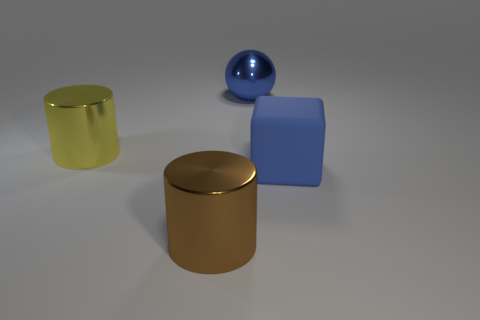Are there any other things that are made of the same material as the blue cube?
Make the answer very short. No. What material is the blue thing that is on the right side of the blue shiny thing?
Your response must be concise. Rubber. Are there fewer blue rubber blocks behind the cube than large matte objects?
Give a very brief answer. Yes. Is the shape of the big yellow shiny object the same as the brown metal thing?
Keep it short and to the point. Yes. Is there anything else that is the same shape as the big yellow metal thing?
Keep it short and to the point. Yes. Are any brown metallic things visible?
Offer a terse response. Yes. There is a brown thing; does it have the same shape as the blue thing that is behind the big rubber object?
Give a very brief answer. No. What material is the cylinder that is to the left of the large metallic object in front of the rubber thing?
Ensure brevity in your answer.  Metal. What color is the large ball?
Your answer should be compact. Blue. There is a cylinder to the right of the yellow cylinder; is its color the same as the large metallic object behind the yellow shiny object?
Provide a short and direct response. No. 